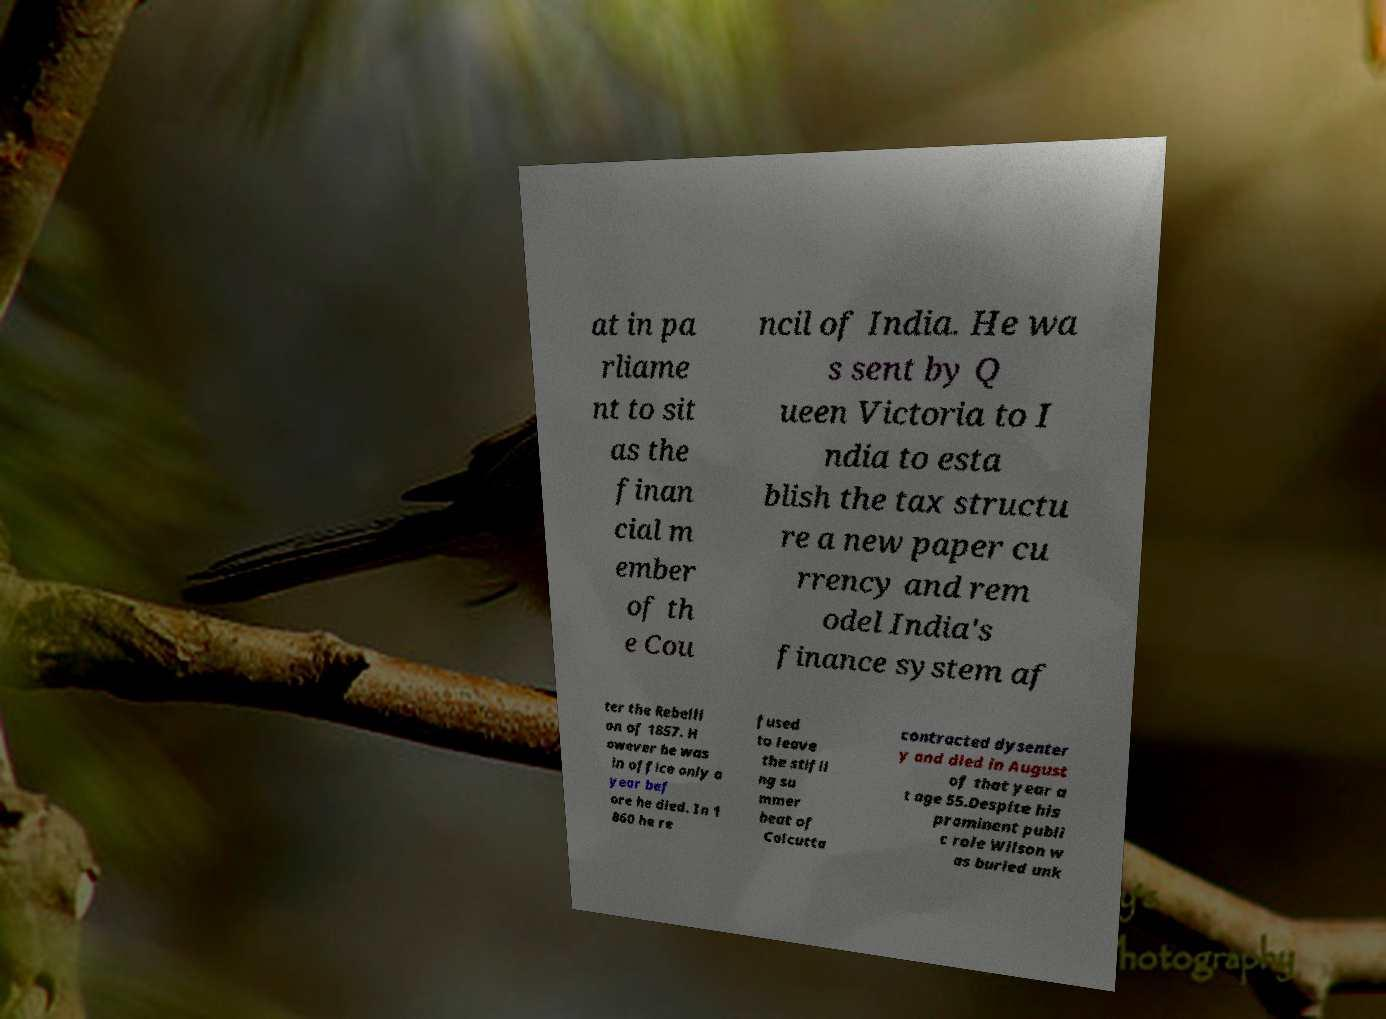Could you assist in decoding the text presented in this image and type it out clearly? at in pa rliame nt to sit as the finan cial m ember of th e Cou ncil of India. He wa s sent by Q ueen Victoria to I ndia to esta blish the tax structu re a new paper cu rrency and rem odel India's finance system af ter the Rebelli on of 1857. H owever he was in office only a year bef ore he died. In 1 860 he re fused to leave the stifli ng su mmer heat of Calcutta contracted dysenter y and died in August of that year a t age 55.Despite his prominent publi c role Wilson w as buried unk 